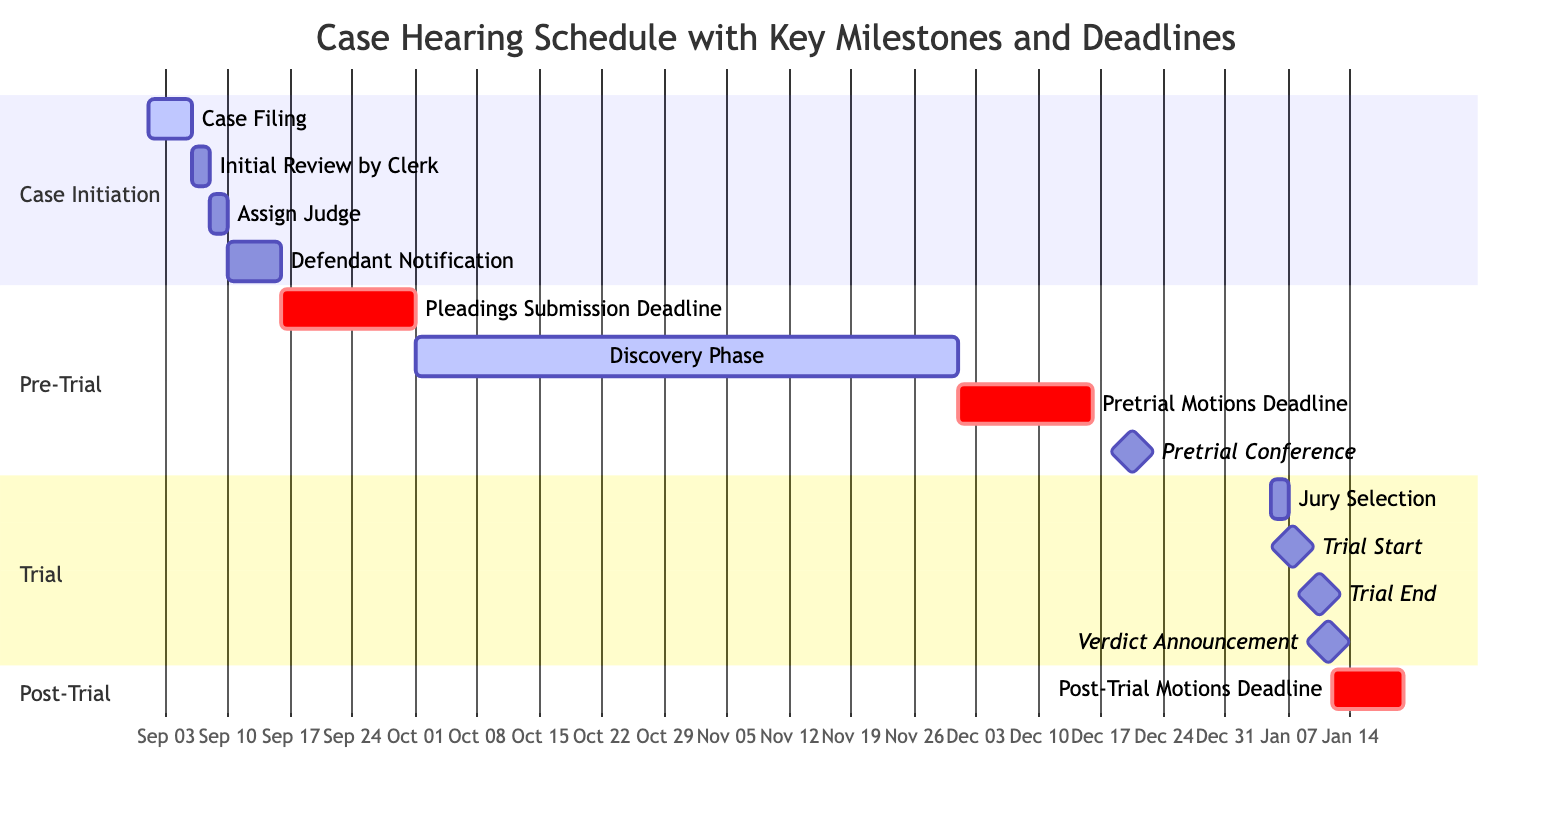What is the duration of the Discovery Phase? The Discovery Phase runs from October 1, 2023, to November 30, 2023. Calculating the duration gives us 61 days.
Answer: 61 days How many key milestones are there in the trial section? In the trial section, there are three key milestones marked: Trial Start, Trial End, and Verdict Announcement. Therefore, the total count is three.
Answer: 3 What is the deadline for Pleadings Submission? The Pleadings Submission Deadline is specified as September 16, 2023, and it lasts for 15 days, concluding on September 30, 2023. The precise deadline date is September 30, 2023.
Answer: September 30, 2023 Which activity immediately follows the Defendant Notification? Following the Defendant Notification concluding on September 15, 2023, the very next activity in the schedule is Pleadings Submission Deadline starting on September 16, 2023.
Answer: Pleadings Submission Deadline When does the Pretrial Conference occur? By examining the Gantt Chart, the Pretrial Conference is denoted as a milestone that occurs on December 20, 2023.
Answer: December 20, 2023 Is the Assisting Judge step took longer than the Initial Review by Clerk? The Assisting Judge task lasts for 2 days, from September 8 to September 9, while the Initial Review by Clerk takes only 2 days from September 6 to September 7. Since both durations are equal, neither took longer than the other.
Answer: No What is the start date of the Post-Trial Motions Deadline? The Post-Trial Motions Deadline is scheduled to begin on January 12, 2024, as represented in the Gantt Chart.
Answer: January 12, 2024 What represents the end date of the Trial End task? The Trial End task in the schedule is clearly indicated to occur on January 10, 2024; thus, this is the end date for that task.
Answer: January 10, 2024 